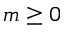<formula> <loc_0><loc_0><loc_500><loc_500>m \geq 0</formula> 